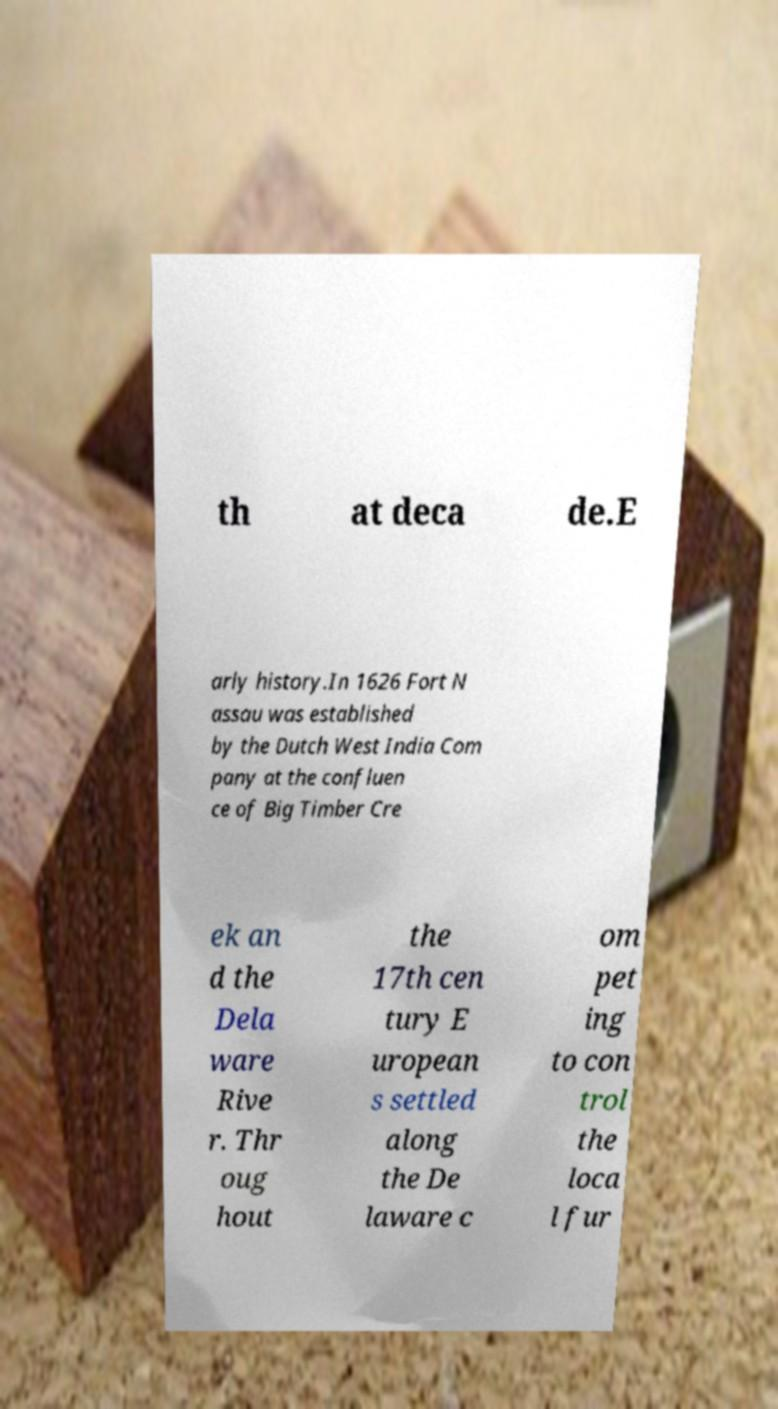Please identify and transcribe the text found in this image. th at deca de.E arly history.In 1626 Fort N assau was established by the Dutch West India Com pany at the confluen ce of Big Timber Cre ek an d the Dela ware Rive r. Thr oug hout the 17th cen tury E uropean s settled along the De laware c om pet ing to con trol the loca l fur 